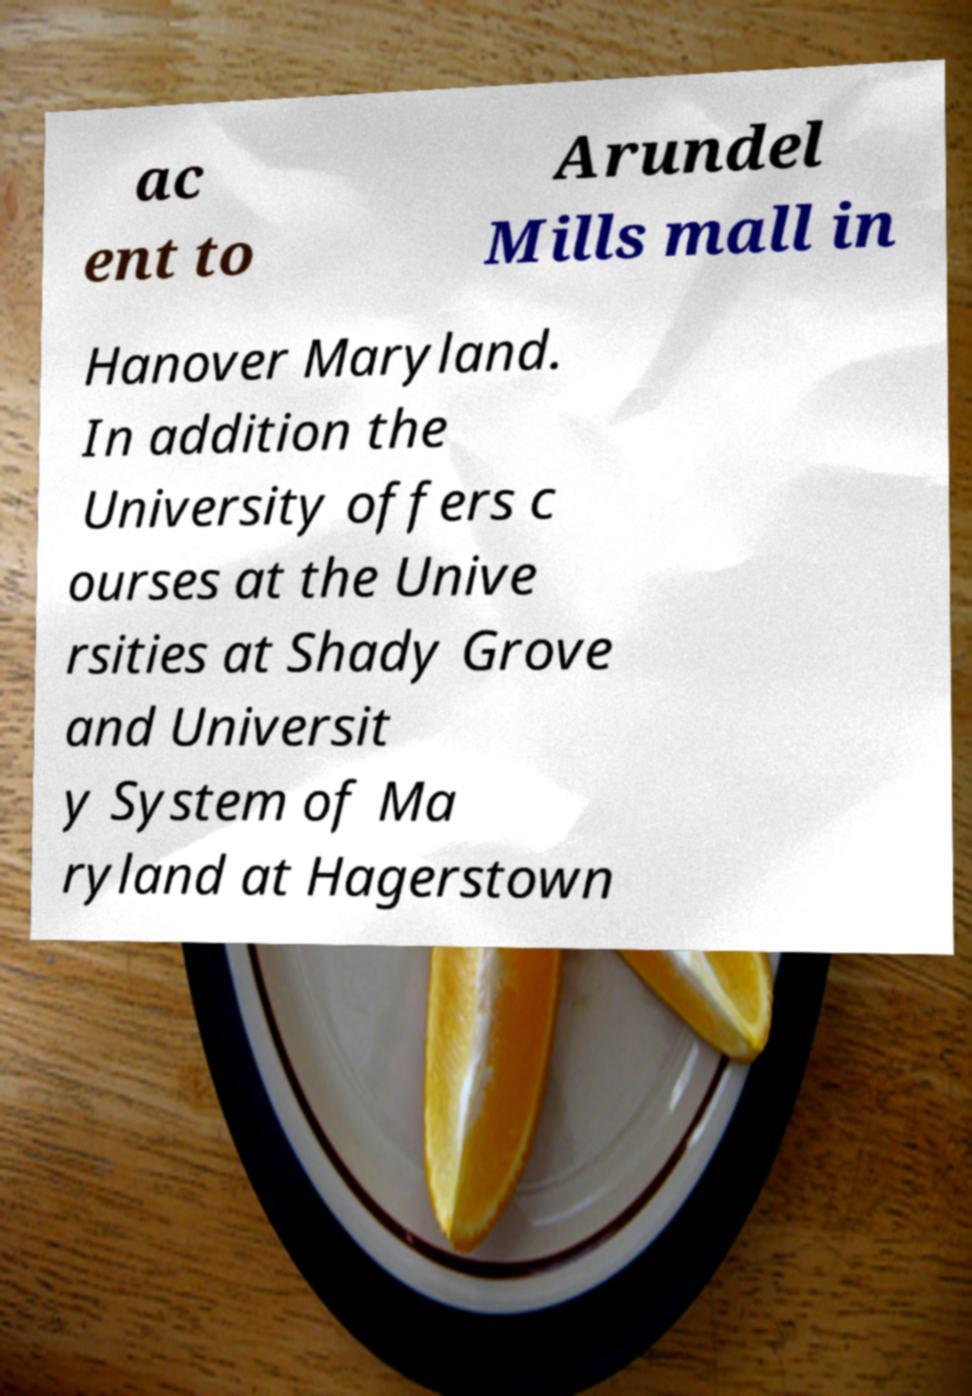Could you extract and type out the text from this image? ac ent to Arundel Mills mall in Hanover Maryland. In addition the University offers c ourses at the Unive rsities at Shady Grove and Universit y System of Ma ryland at Hagerstown 